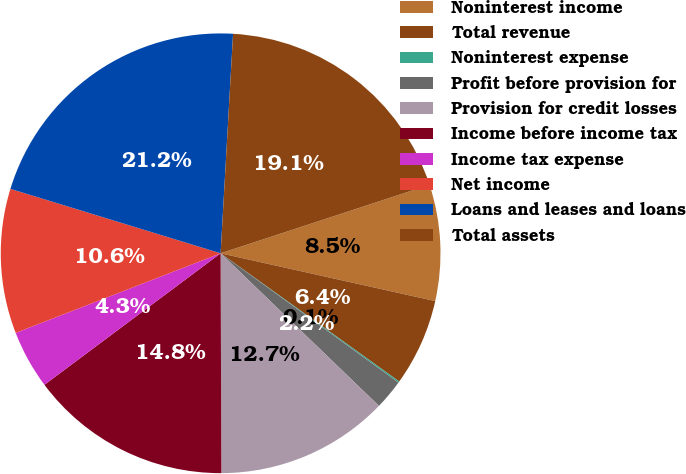Convert chart to OTSL. <chart><loc_0><loc_0><loc_500><loc_500><pie_chart><fcel>Noninterest income<fcel>Total revenue<fcel>Noninterest expense<fcel>Profit before provision for<fcel>Provision for credit losses<fcel>Income before income tax<fcel>Income tax expense<fcel>Net income<fcel>Loans and leases and loans<fcel>Total assets<nl><fcel>8.53%<fcel>6.42%<fcel>0.1%<fcel>2.2%<fcel>12.74%<fcel>14.85%<fcel>4.31%<fcel>10.63%<fcel>21.17%<fcel>19.06%<nl></chart> 